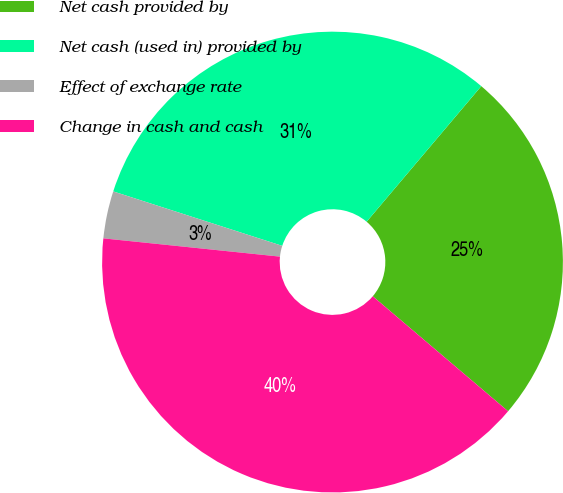<chart> <loc_0><loc_0><loc_500><loc_500><pie_chart><fcel>Net cash provided by<fcel>Net cash (used in) provided by<fcel>Effect of exchange rate<fcel>Change in cash and cash<nl><fcel>25.04%<fcel>31.21%<fcel>3.32%<fcel>40.43%<nl></chart> 